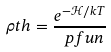<formula> <loc_0><loc_0><loc_500><loc_500>\rho t h = \frac { e ^ { - \mathcal { H } / k T } } { \ p f u n }</formula> 